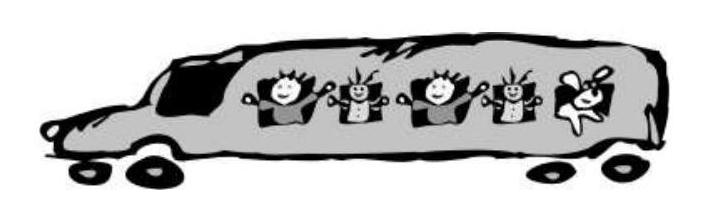A trip of the pupils to the zoo took 135 minutes.
How many hours and minutes does it make? Choices: ['3 h 5 min', '2 h 15 min', '1 h 35 min', '2 h 35 min', '3 h 35 min'] Answer is B. 